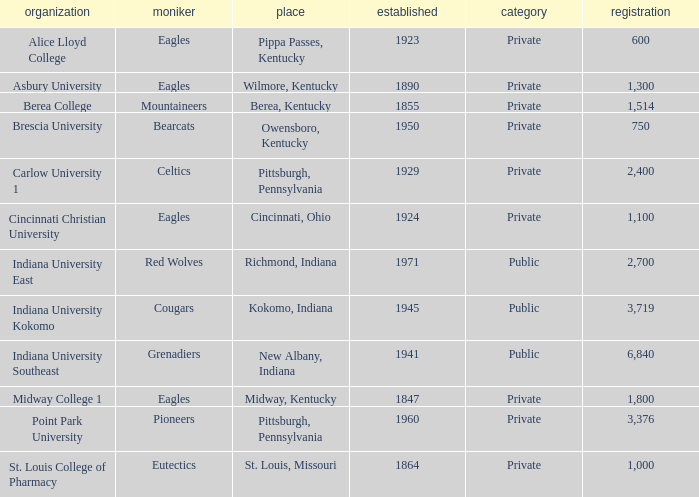Which public college has a nickname of The Grenadiers? Indiana University Southeast. 